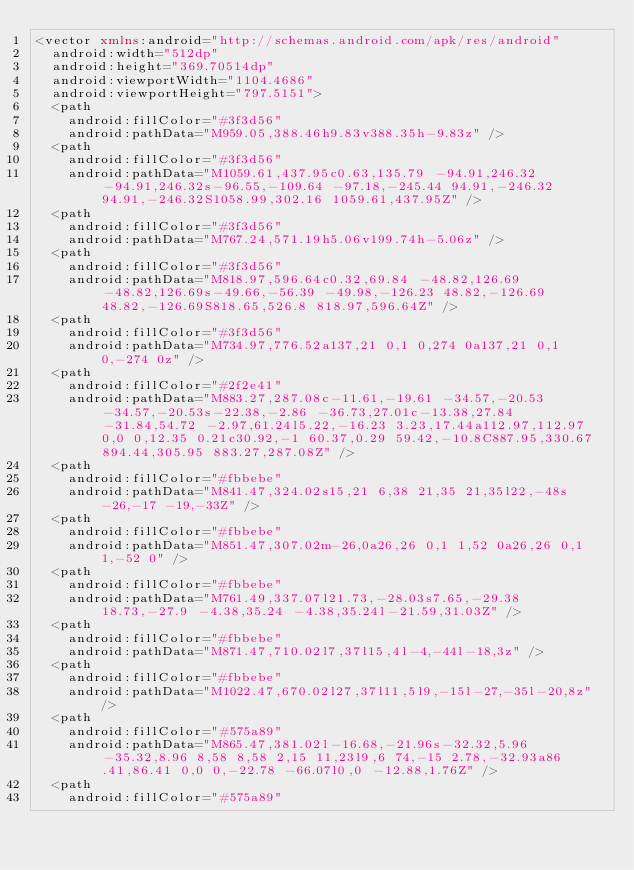Convert code to text. <code><loc_0><loc_0><loc_500><loc_500><_XML_><vector xmlns:android="http://schemas.android.com/apk/res/android"
  android:width="512dp"
  android:height="369.70514dp"
  android:viewportWidth="1104.4686"
  android:viewportHeight="797.5151">
  <path
    android:fillColor="#3f3d56"
    android:pathData="M959.05,388.46h9.83v388.35h-9.83z" />
  <path
    android:fillColor="#3f3d56"
    android:pathData="M1059.61,437.95c0.63,135.79 -94.91,246.32 -94.91,246.32s-96.55,-109.64 -97.18,-245.44 94.91,-246.32 94.91,-246.32S1058.99,302.16 1059.61,437.95Z" />
  <path
    android:fillColor="#3f3d56"
    android:pathData="M767.24,571.19h5.06v199.74h-5.06z" />
  <path
    android:fillColor="#3f3d56"
    android:pathData="M818.97,596.64c0.32,69.84 -48.82,126.69 -48.82,126.69s-49.66,-56.39 -49.98,-126.23 48.82,-126.69 48.82,-126.69S818.65,526.8 818.97,596.64Z" />
  <path
    android:fillColor="#3f3d56"
    android:pathData="M734.97,776.52a137,21 0,1 0,274 0a137,21 0,1 0,-274 0z" />
  <path
    android:fillColor="#2f2e41"
    android:pathData="M883.27,287.08c-11.61,-19.61 -34.57,-20.53 -34.57,-20.53s-22.38,-2.86 -36.73,27.01c-13.38,27.84 -31.84,54.72 -2.97,61.24l5.22,-16.23 3.23,17.44a112.97,112.97 0,0 0,12.35 0.21c30.92,-1 60.37,0.29 59.42,-10.8C887.95,330.67 894.44,305.95 883.27,287.08Z" />
  <path
    android:fillColor="#fbbebe"
    android:pathData="M841.47,324.02s15,21 6,38 21,35 21,35l22,-48s-26,-17 -19,-33Z" />
  <path
    android:fillColor="#fbbebe"
    android:pathData="M851.47,307.02m-26,0a26,26 0,1 1,52 0a26,26 0,1 1,-52 0" />
  <path
    android:fillColor="#fbbebe"
    android:pathData="M761.49,337.07l21.73,-28.03s7.65,-29.38 18.73,-27.9 -4.38,35.24 -4.38,35.24l-21.59,31.03Z" />
  <path
    android:fillColor="#fbbebe"
    android:pathData="M871.47,710.02l7,37l15,4l-4,-44l-18,3z" />
  <path
    android:fillColor="#fbbebe"
    android:pathData="M1022.47,670.02l27,37l11,5l9,-15l-27,-35l-20,8z" />
  <path
    android:fillColor="#575a89"
    android:pathData="M865.47,381.02l-16.68,-21.96s-32.32,5.96 -35.32,8.96 8,58 8,58 2,15 11,23l9,6 74,-15 2.78,-32.93a86.41,86.41 0,0 0,-22.78 -66.07l0,0 -12.88,1.76Z" />
  <path
    android:fillColor="#575a89"</code> 